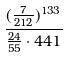Convert formula to latex. <formula><loc_0><loc_0><loc_500><loc_500>\frac { ( \frac { 7 } { 2 1 2 } ) ^ { 1 3 3 } } { \frac { 2 4 } { 5 5 } \cdot 4 4 1 }</formula> 